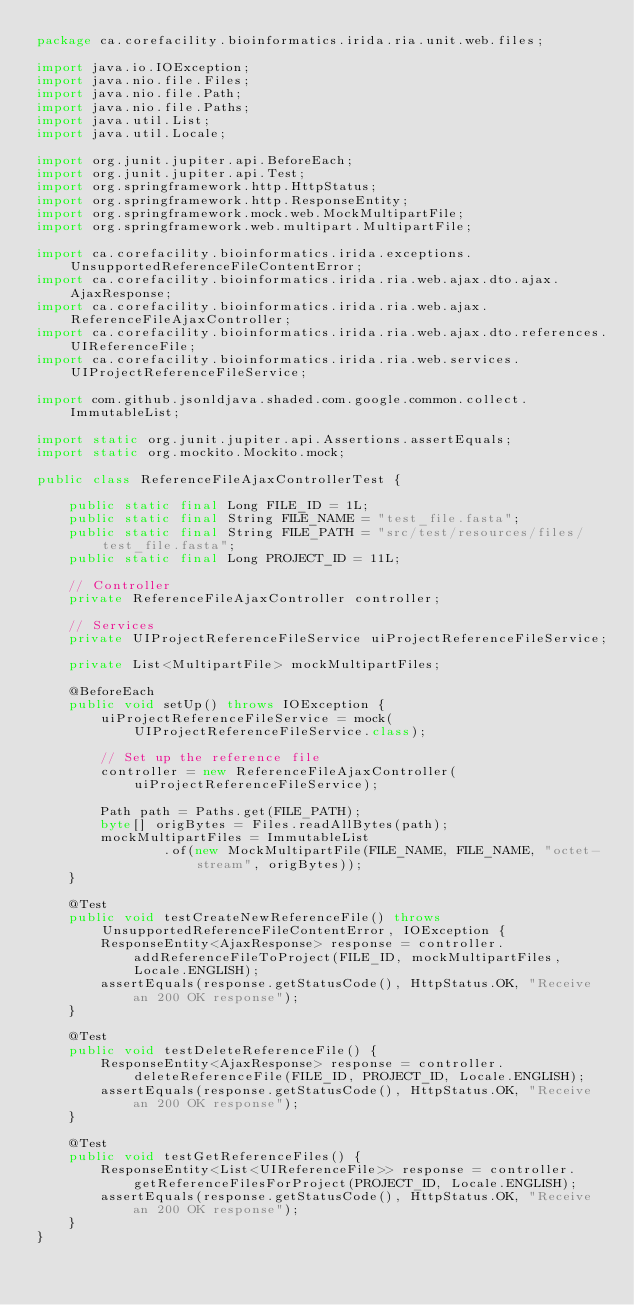<code> <loc_0><loc_0><loc_500><loc_500><_Java_>package ca.corefacility.bioinformatics.irida.ria.unit.web.files;

import java.io.IOException;
import java.nio.file.Files;
import java.nio.file.Path;
import java.nio.file.Paths;
import java.util.List;
import java.util.Locale;

import org.junit.jupiter.api.BeforeEach;
import org.junit.jupiter.api.Test;
import org.springframework.http.HttpStatus;
import org.springframework.http.ResponseEntity;
import org.springframework.mock.web.MockMultipartFile;
import org.springframework.web.multipart.MultipartFile;

import ca.corefacility.bioinformatics.irida.exceptions.UnsupportedReferenceFileContentError;
import ca.corefacility.bioinformatics.irida.ria.web.ajax.dto.ajax.AjaxResponse;
import ca.corefacility.bioinformatics.irida.ria.web.ajax.ReferenceFileAjaxController;
import ca.corefacility.bioinformatics.irida.ria.web.ajax.dto.references.UIReferenceFile;
import ca.corefacility.bioinformatics.irida.ria.web.services.UIProjectReferenceFileService;

import com.github.jsonldjava.shaded.com.google.common.collect.ImmutableList;

import static org.junit.jupiter.api.Assertions.assertEquals;
import static org.mockito.Mockito.mock;

public class ReferenceFileAjaxControllerTest {

	public static final Long FILE_ID = 1L;
	public static final String FILE_NAME = "test_file.fasta";
	public static final String FILE_PATH = "src/test/resources/files/test_file.fasta";
	public static final Long PROJECT_ID = 11L;

	// Controller
	private ReferenceFileAjaxController controller;

	// Services
	private UIProjectReferenceFileService uiProjectReferenceFileService;

	private List<MultipartFile> mockMultipartFiles;

	@BeforeEach
	public void setUp() throws IOException {
		uiProjectReferenceFileService = mock(UIProjectReferenceFileService.class);

		// Set up the reference file
		controller = new ReferenceFileAjaxController(uiProjectReferenceFileService);

		Path path = Paths.get(FILE_PATH);
		byte[] origBytes = Files.readAllBytes(path);
		mockMultipartFiles = ImmutableList
				.of(new MockMultipartFile(FILE_NAME, FILE_NAME, "octet-stream", origBytes));
	}

	@Test
	public void testCreateNewReferenceFile() throws UnsupportedReferenceFileContentError, IOException {
		ResponseEntity<AjaxResponse> response = controller.addReferenceFileToProject(FILE_ID, mockMultipartFiles, Locale.ENGLISH);
		assertEquals(response.getStatusCode(), HttpStatus.OK, "Receive an 200 OK response");
	}

	@Test
	public void testDeleteReferenceFile() {
		ResponseEntity<AjaxResponse> response = controller.deleteReferenceFile(FILE_ID, PROJECT_ID, Locale.ENGLISH);
		assertEquals(response.getStatusCode(), HttpStatus.OK, "Receive an 200 OK response");
	}

	@Test
	public void testGetReferenceFiles() {
		ResponseEntity<List<UIReferenceFile>> response = controller.getReferenceFilesForProject(PROJECT_ID, Locale.ENGLISH);
		assertEquals(response.getStatusCode(), HttpStatus.OK, "Receive an 200 OK response");
	}
}
</code> 